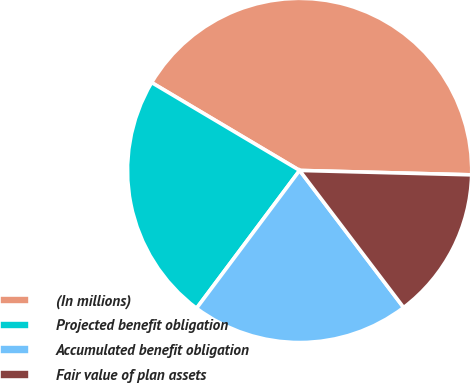Convert chart. <chart><loc_0><loc_0><loc_500><loc_500><pie_chart><fcel>(In millions)<fcel>Projected benefit obligation<fcel>Accumulated benefit obligation<fcel>Fair value of plan assets<nl><fcel>41.88%<fcel>23.31%<fcel>20.55%<fcel>14.26%<nl></chart> 